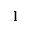Convert formula to latex. <formula><loc_0><loc_0><loc_500><loc_500>\mathbf l</formula> 